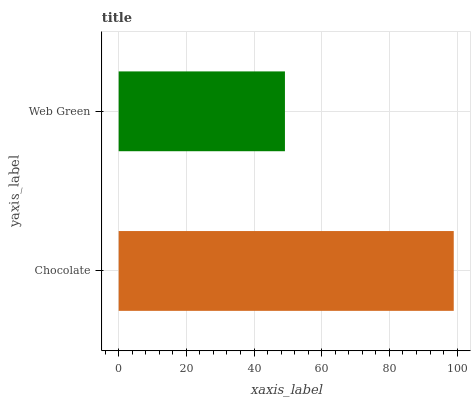Is Web Green the minimum?
Answer yes or no. Yes. Is Chocolate the maximum?
Answer yes or no. Yes. Is Web Green the maximum?
Answer yes or no. No. Is Chocolate greater than Web Green?
Answer yes or no. Yes. Is Web Green less than Chocolate?
Answer yes or no. Yes. Is Web Green greater than Chocolate?
Answer yes or no. No. Is Chocolate less than Web Green?
Answer yes or no. No. Is Chocolate the high median?
Answer yes or no. Yes. Is Web Green the low median?
Answer yes or no. Yes. Is Web Green the high median?
Answer yes or no. No. Is Chocolate the low median?
Answer yes or no. No. 